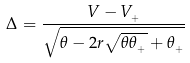Convert formula to latex. <formula><loc_0><loc_0><loc_500><loc_500>\Delta = \frac { V - V _ { _ { + } } } { \sqrt { \theta - 2 r \sqrt { \theta \theta _ { _ { + } } } + \theta _ { _ { + } } } }</formula> 